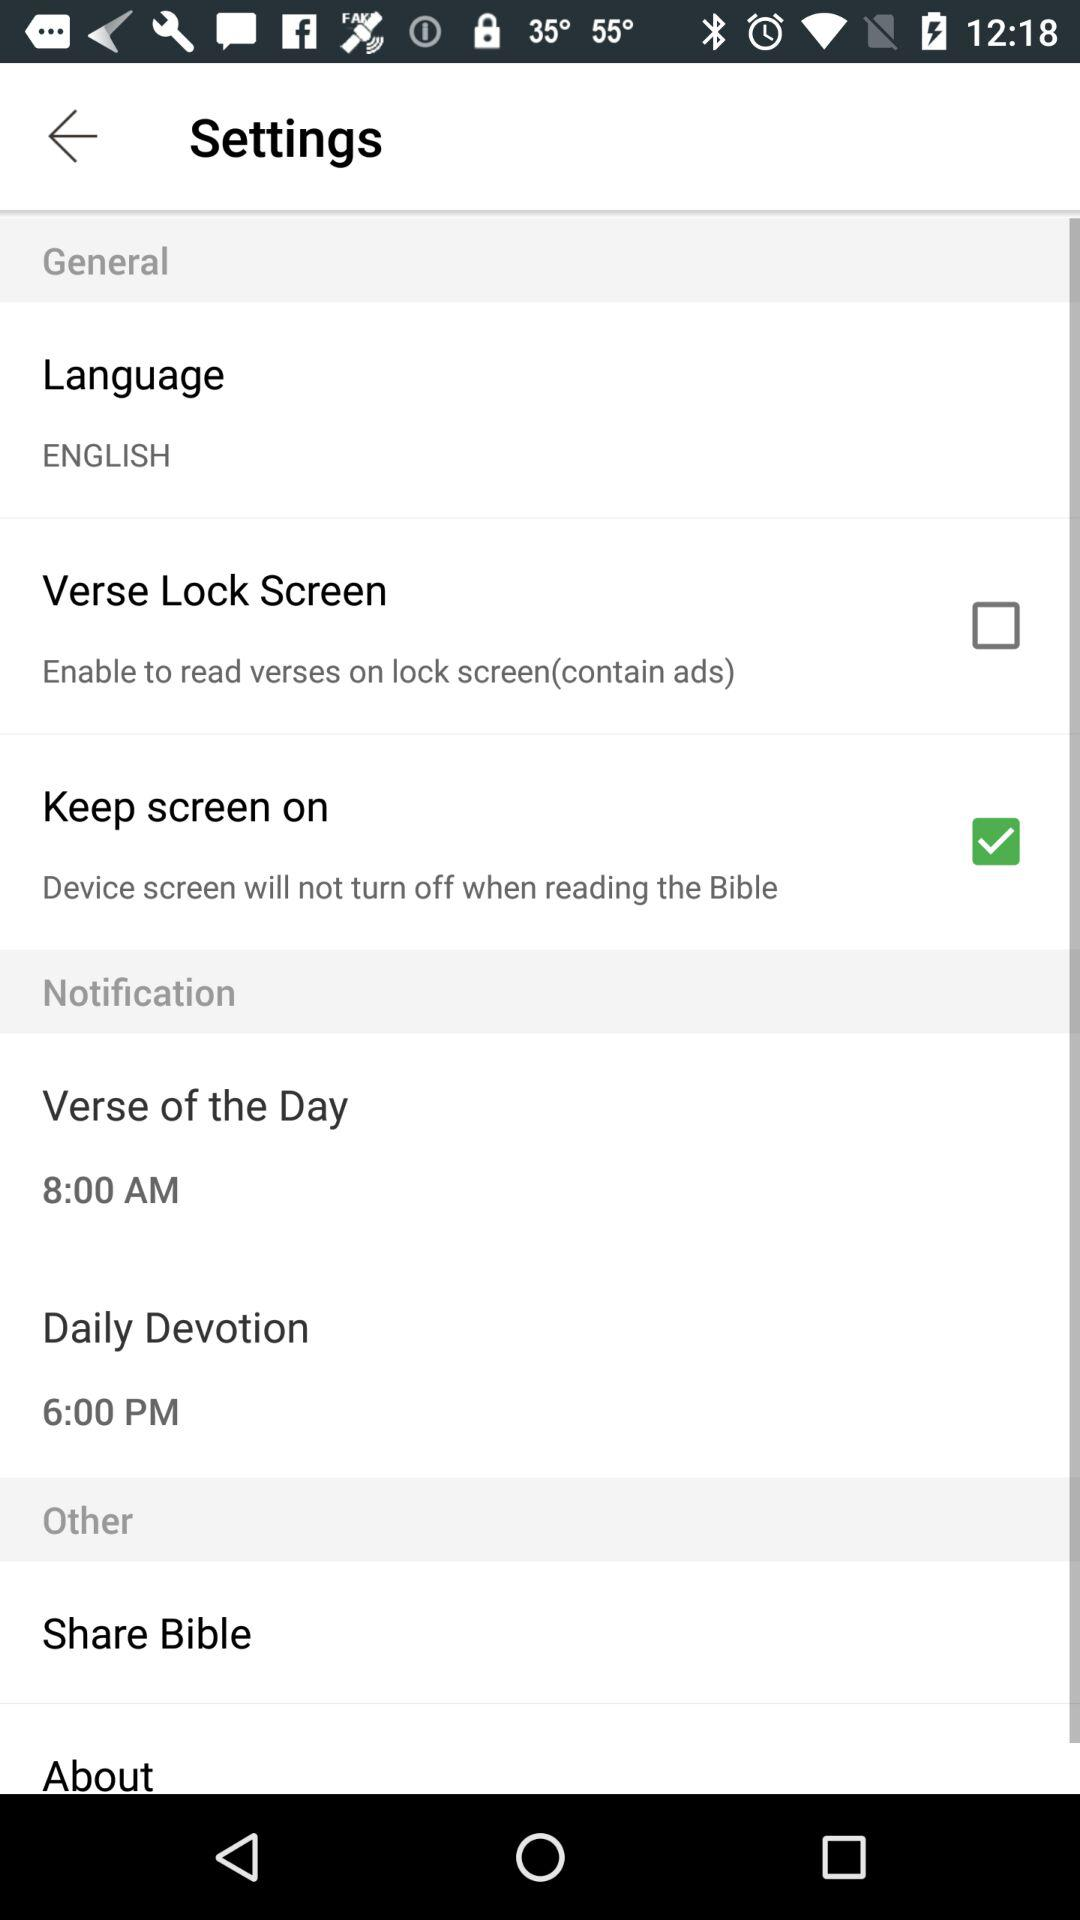What is the status of the "Verse Lock Screen" setting? The status is "off". 